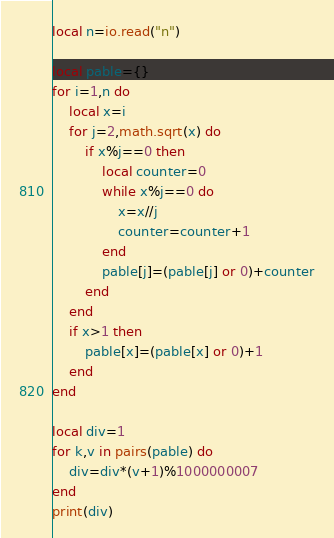Convert code to text. <code><loc_0><loc_0><loc_500><loc_500><_Lua_>local n=io.read("n")

local pable={}
for i=1,n do
    local x=i
    for j=2,math.sqrt(x) do
        if x%j==0 then
            local counter=0
            while x%j==0 do
                x=x//j
                counter=counter+1
            end
            pable[j]=(pable[j] or 0)+counter
        end
    end
    if x>1 then
        pable[x]=(pable[x] or 0)+1
    end
end

local div=1
for k,v in pairs(pable) do
    div=div*(v+1)%1000000007
end
print(div)</code> 